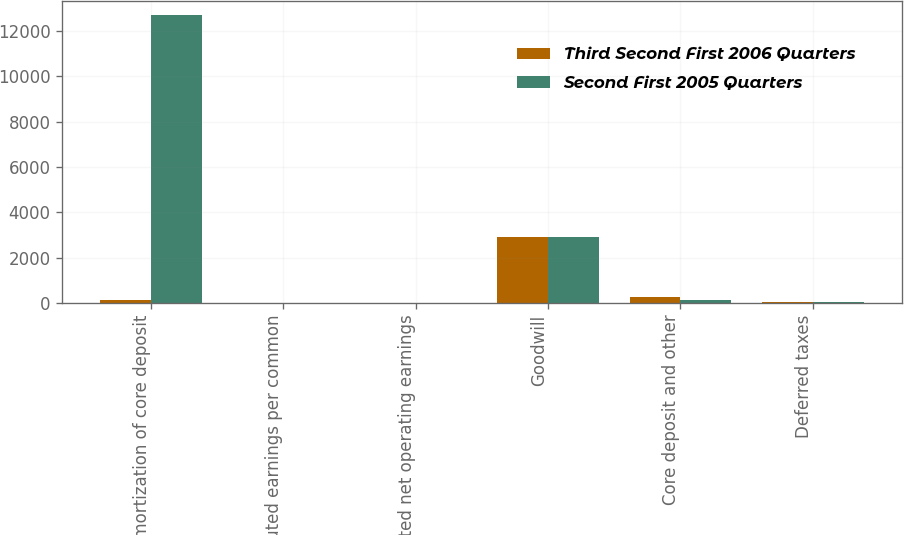Convert chart to OTSL. <chart><loc_0><loc_0><loc_500><loc_500><stacked_bar_chart><ecel><fcel>Amortization of core deposit<fcel>Diluted earnings per common<fcel>Diluted net operating earnings<fcel>Goodwill<fcel>Core deposit and other<fcel>Deferred taxes<nl><fcel>Third Second First 2006 Quarters<fcel>115<fcel>1.88<fcel>1.98<fcel>2909<fcel>261<fcel>32<nl><fcel>Second First 2005 Quarters<fcel>12703<fcel>1.78<fcel>1.85<fcel>2904<fcel>115<fcel>44<nl></chart> 